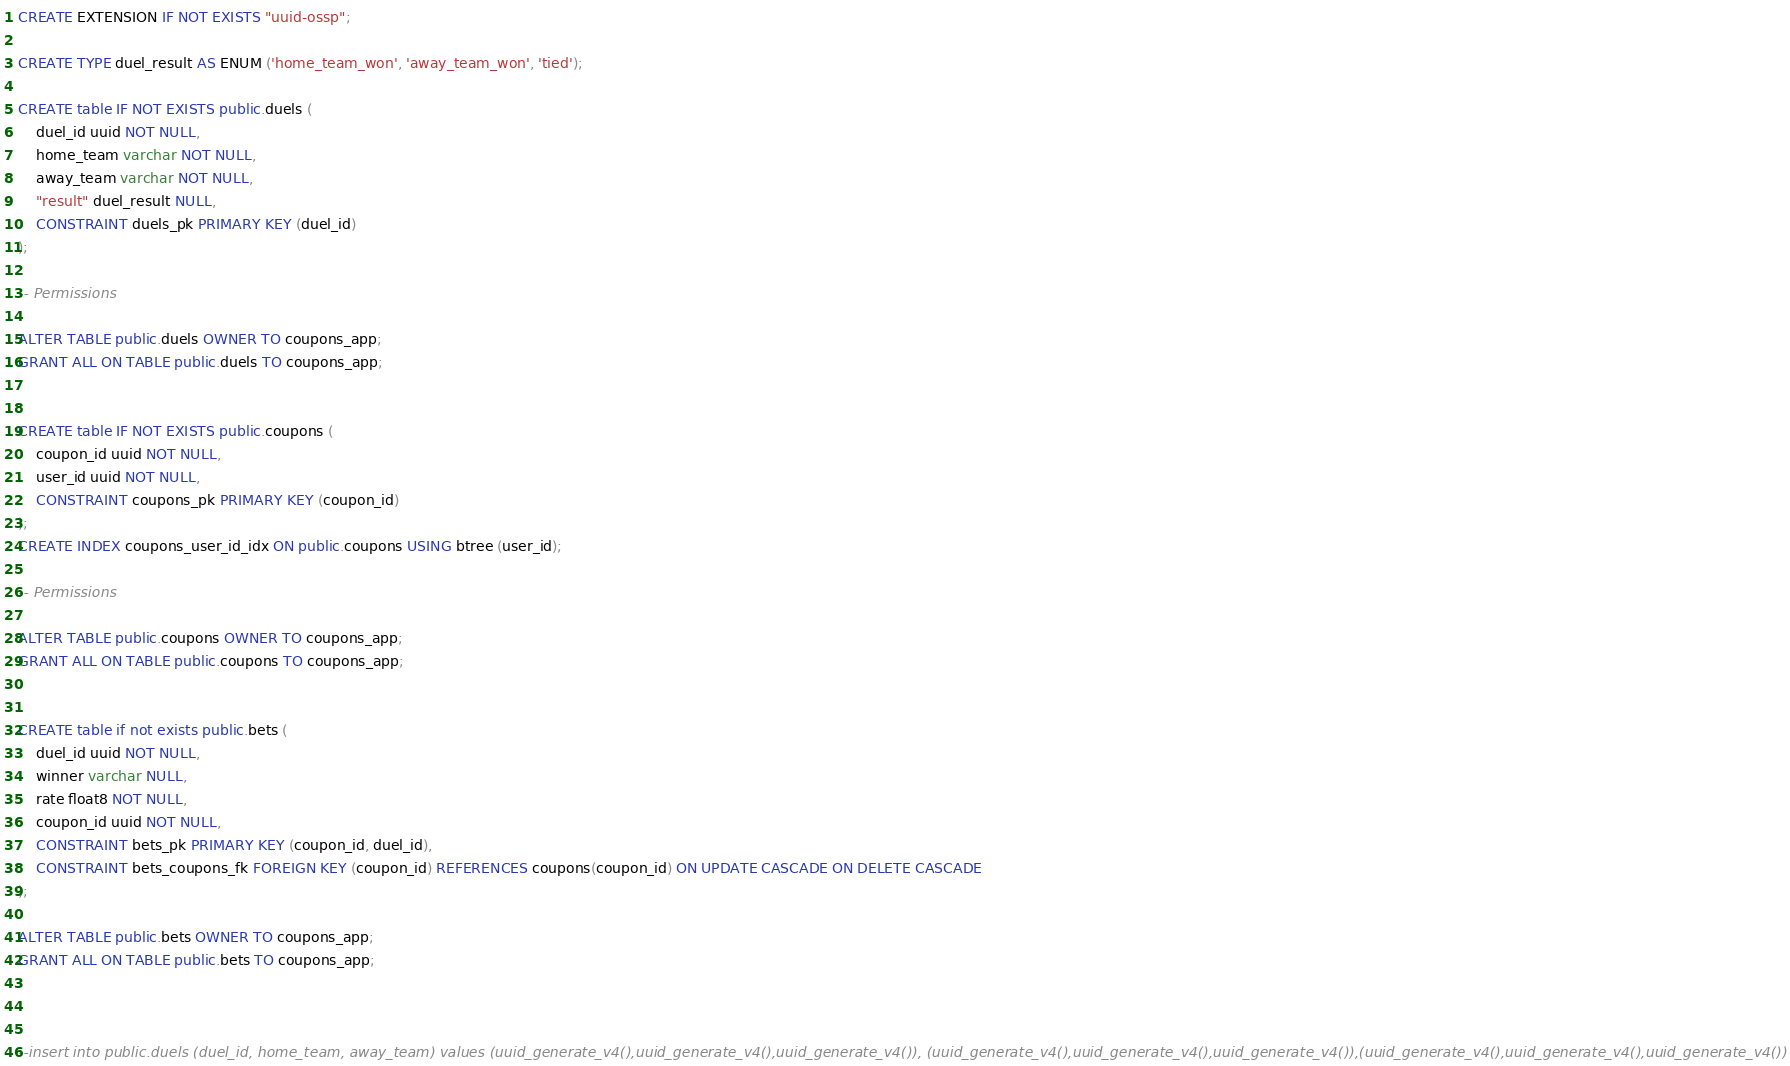Convert code to text. <code><loc_0><loc_0><loc_500><loc_500><_SQL_>CREATE EXTENSION IF NOT EXISTS "uuid-ossp";

CREATE TYPE duel_result AS ENUM ('home_team_won', 'away_team_won', 'tied');

CREATE table IF NOT EXISTS public.duels (
	duel_id uuid NOT NULL,
	home_team varchar NOT NULL,
	away_team varchar NOT NULL,
	"result" duel_result NULL,
	CONSTRAINT duels_pk PRIMARY KEY (duel_id)
);

-- Permissions

ALTER TABLE public.duels OWNER TO coupons_app;
GRANT ALL ON TABLE public.duels TO coupons_app;


CREATE table IF NOT EXISTS public.coupons (
	coupon_id uuid NOT NULL,
	user_id uuid NOT NULL,
	CONSTRAINT coupons_pk PRIMARY KEY (coupon_id)
);
CREATE INDEX coupons_user_id_idx ON public.coupons USING btree (user_id);

-- Permissions

ALTER TABLE public.coupons OWNER TO coupons_app;
GRANT ALL ON TABLE public.coupons TO coupons_app;


CREATE table if not exists public.bets (
	duel_id uuid NOT NULL,
	winner varchar NULL,
	rate float8 NOT NULL,
	coupon_id uuid NOT NULL,
	CONSTRAINT bets_pk PRIMARY KEY (coupon_id, duel_id),
	CONSTRAINT bets_coupons_fk FOREIGN KEY (coupon_id) REFERENCES coupons(coupon_id) ON UPDATE CASCADE ON DELETE CASCADE
);

ALTER TABLE public.bets OWNER TO coupons_app;
GRANT ALL ON TABLE public.bets TO coupons_app;



--insert into public.duels (duel_id, home_team, away_team) values (uuid_generate_v4(),uuid_generate_v4(),uuid_generate_v4()), (uuid_generate_v4(),uuid_generate_v4(),uuid_generate_v4()),(uuid_generate_v4(),uuid_generate_v4(),uuid_generate_v4())
</code> 